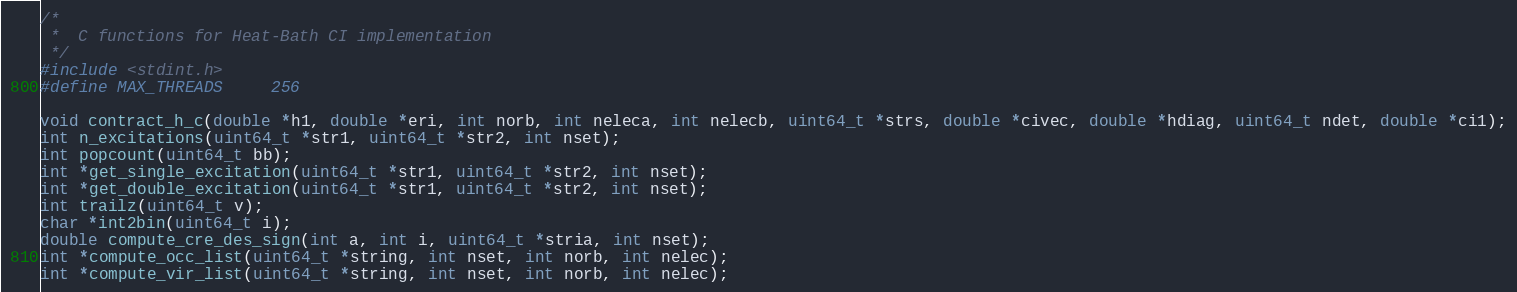<code> <loc_0><loc_0><loc_500><loc_500><_C_>/*
 *  C functions for Heat-Bath CI implementation
 */
#include <stdint.h>
#define MAX_THREADS     256

void contract_h_c(double *h1, double *eri, int norb, int neleca, int nelecb, uint64_t *strs, double *civec, double *hdiag, uint64_t ndet, double *ci1);
int n_excitations(uint64_t *str1, uint64_t *str2, int nset);
int popcount(uint64_t bb);
int *get_single_excitation(uint64_t *str1, uint64_t *str2, int nset);
int *get_double_excitation(uint64_t *str1, uint64_t *str2, int nset);
int trailz(uint64_t v);
char *int2bin(uint64_t i);
double compute_cre_des_sign(int a, int i, uint64_t *stria, int nset);
int *compute_occ_list(uint64_t *string, int nset, int norb, int nelec);
int *compute_vir_list(uint64_t *string, int nset, int norb, int nelec);</code> 